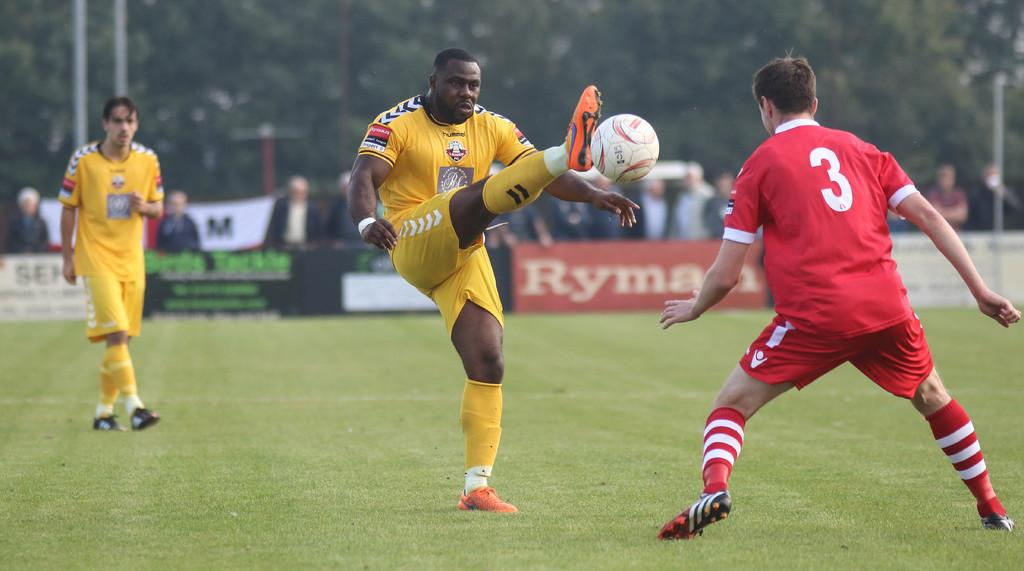How many people are standing in the ground in the image? There are three people standing in the ground in the image. What is the position of the person in the center? The person in the center is kicking a ball. What can be seen in the background of the image? There is a group of people and trees visible in the background. What else is present in the background of the image? Banners are present in the background. How many legs does the bun have in the image? There is no bun present in the image, so it is not possible to determine the number of legs it might have. 